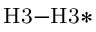<formula> <loc_0><loc_0><loc_500><loc_500>_ { H } 3 - H 3 *</formula> 